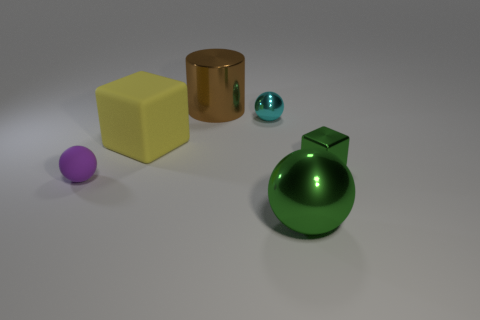Do the block in front of the rubber block and the big cylinder have the same size? No, they do not have the same size. The block in front of the rubber block is a cube with visibly smaller dimensions compared to the big cylinder, which has a larger height and diameter. 